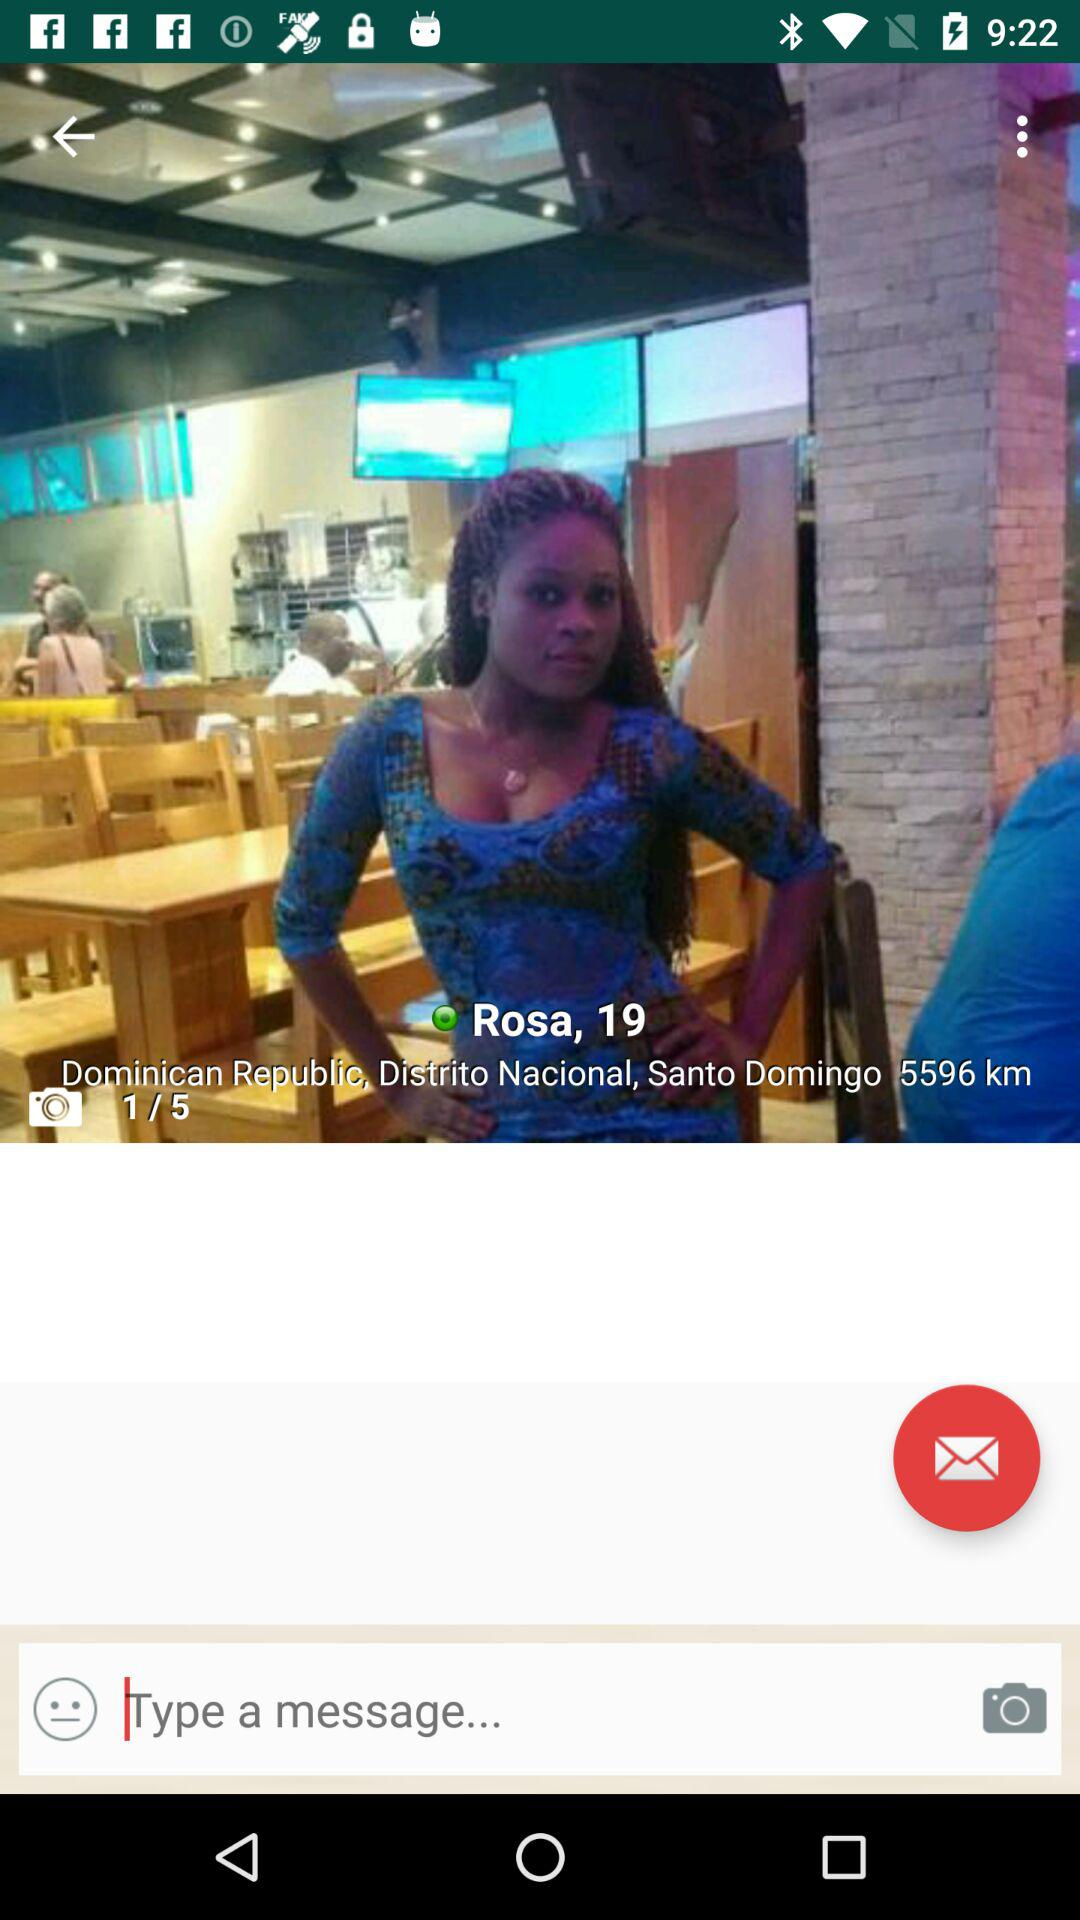What's the name of the person? The name of the person is Rosa. 